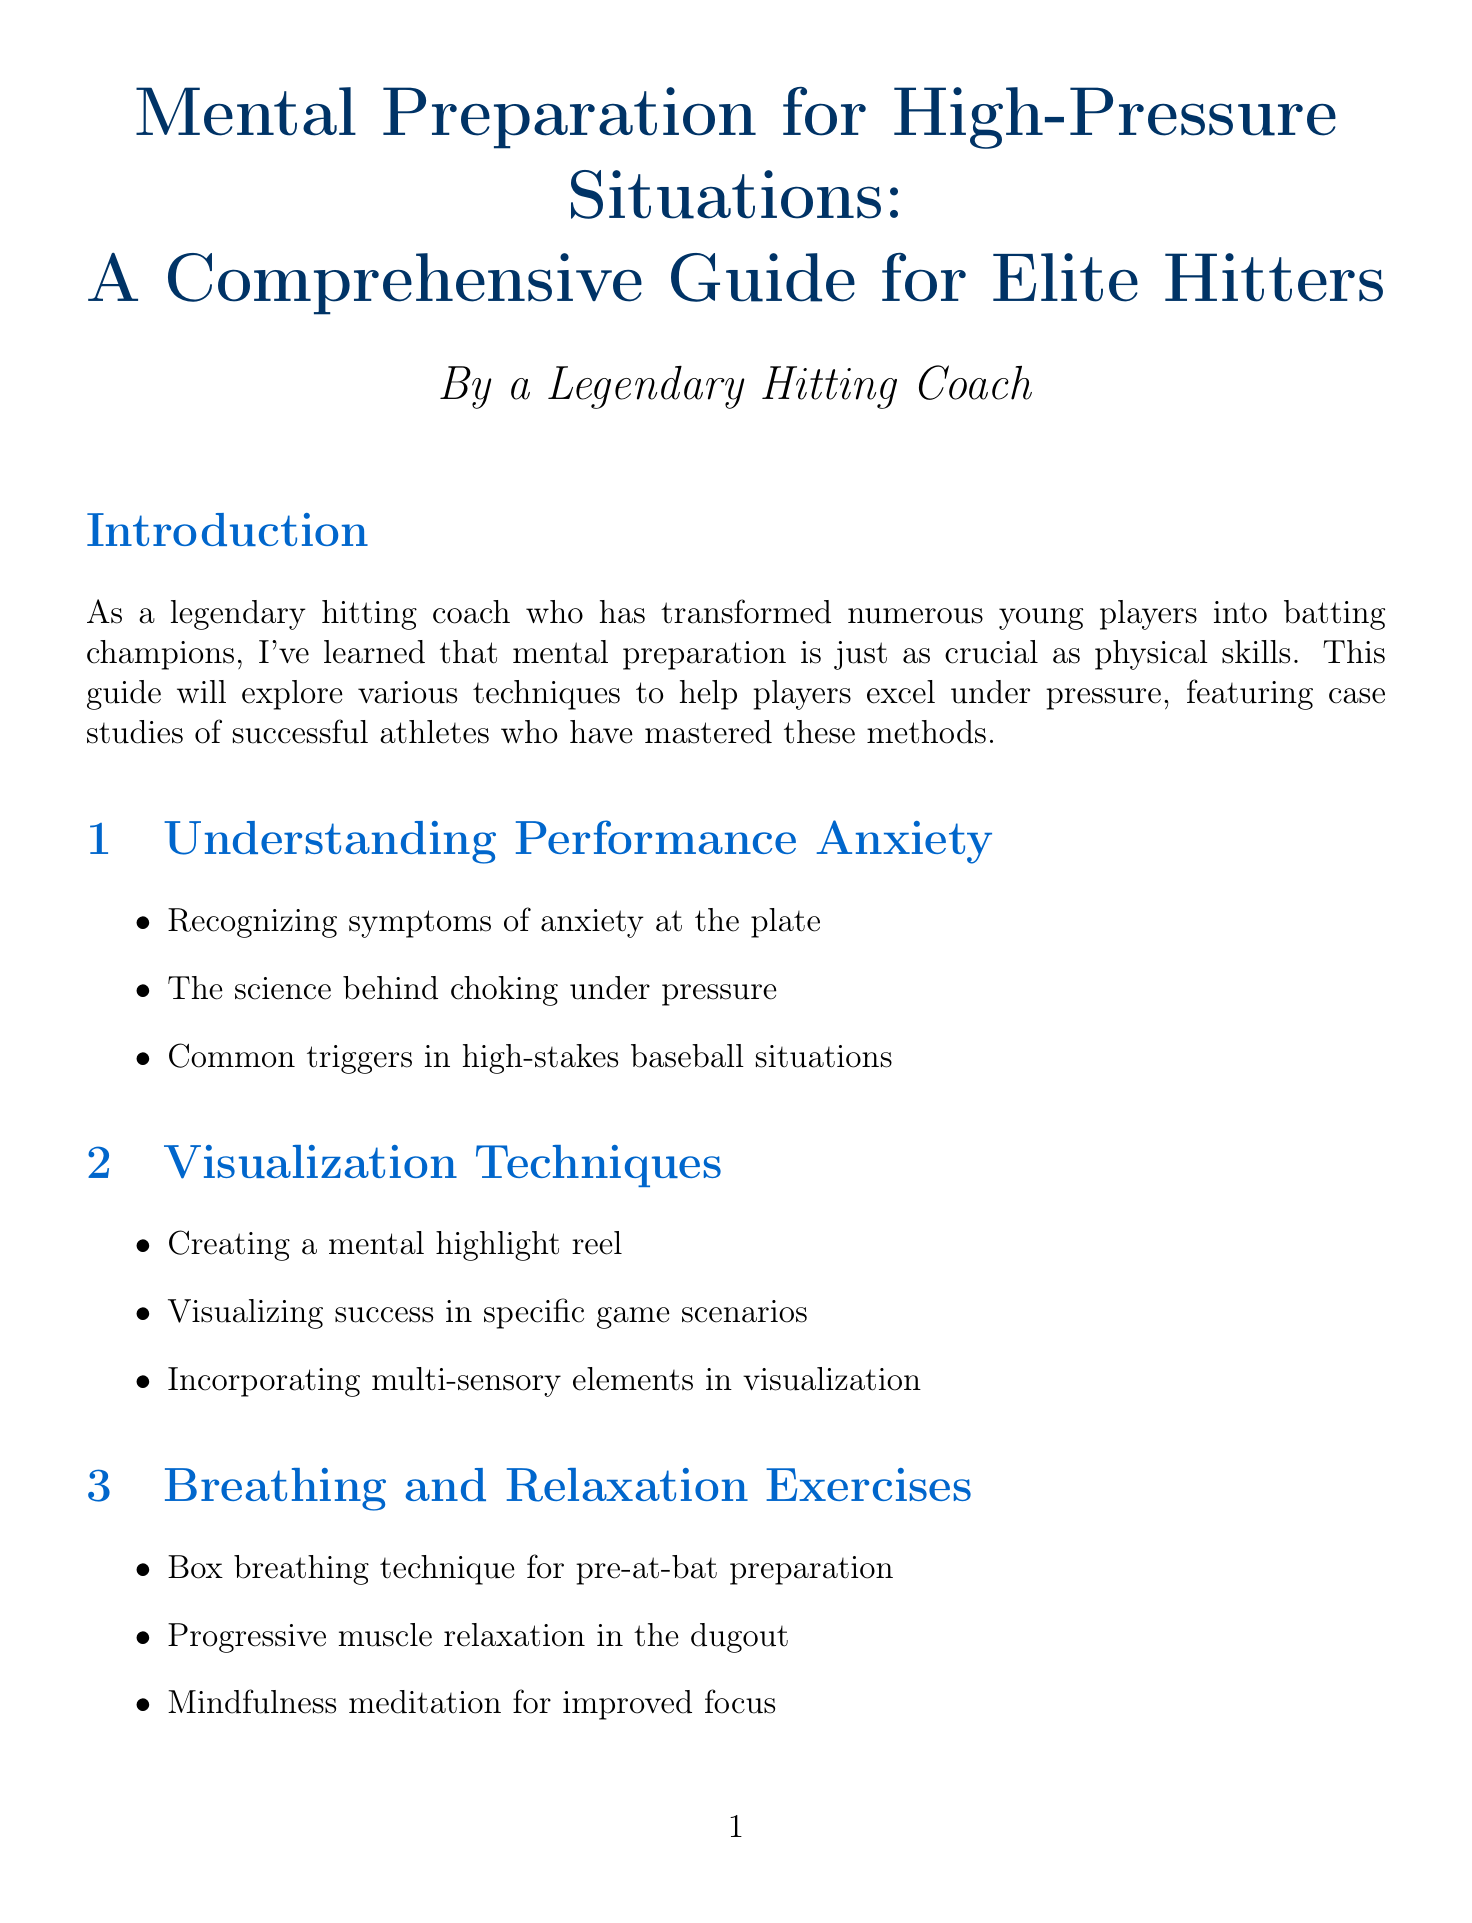What is the title of the document? The title is explicitly mentioned at the beginning of the document.
Answer: Mental Preparation for High-Pressure Situations: A Comprehensive Guide for Elite Hitters How many chapters are in the guide? The total number of chapters is listed in the table of contents section of the document.
Answer: Six What technique did Derek Jeter use? The document specifies the technique associated with Derek Jeter in his case study.
Answer: Visualization What is a key symptom of performance anxiety mentioned? The symptoms of anxiety at the plate are outlined in the chapter on performance anxiety.
Answer: Anxiety at the plate Which player is associated with routine development? The document identifies which player utilized routine development in their case study.
Answer: Chipper Jones How long should the mental imagery workout be practiced daily? The recommended duration for practicing the mental imagery workout is provided in the exercises section.
Answer: 10-15 minutes What type of goals does the document suggest setting? The guide categorizes the recommended goal types in the goal setting chapter.
Answer: SMART goals What relaxation exercise is mentioned for pre-at-bat preparation? The relaxation exercises section describes specific exercises used before batting.
Answer: Box breathing technique 